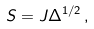Convert formula to latex. <formula><loc_0><loc_0><loc_500><loc_500>S = J \Delta ^ { 1 / 2 } \, ,</formula> 